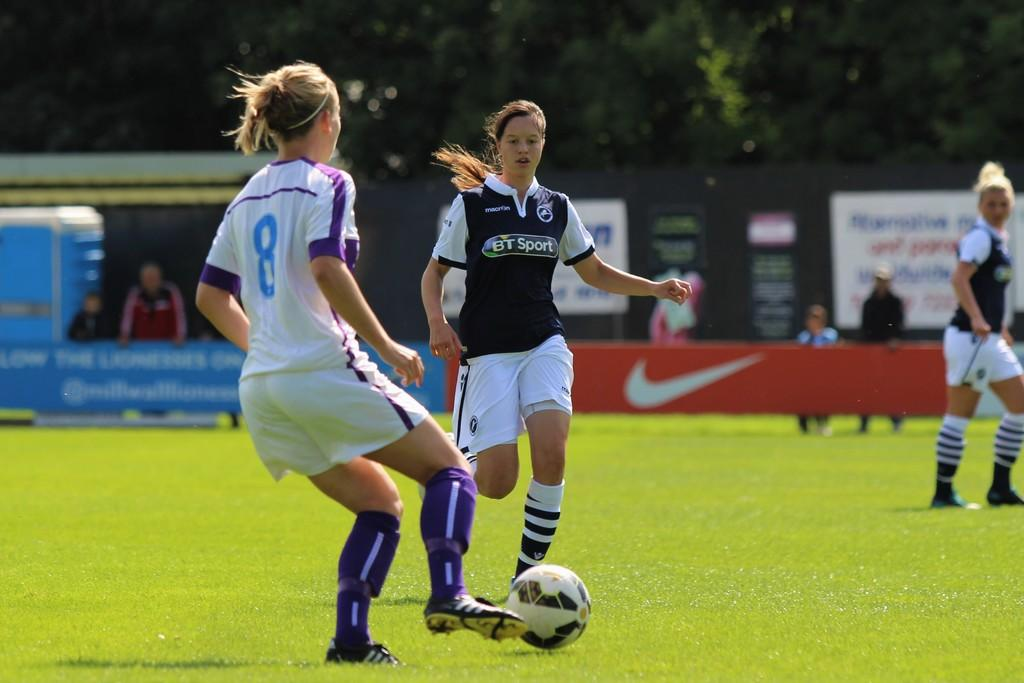<image>
Give a short and clear explanation of the subsequent image. A woman in a black and white strip sponsered by BT sport goes to tackle an opponent wearing white in a football match watched by a few spectators. 